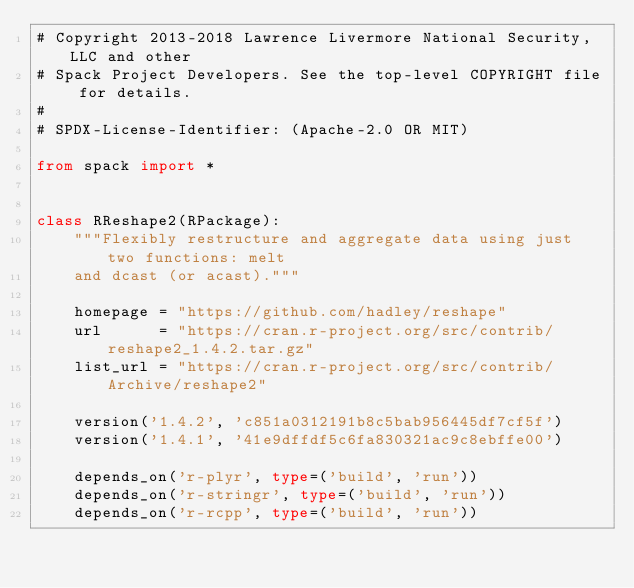Convert code to text. <code><loc_0><loc_0><loc_500><loc_500><_Python_># Copyright 2013-2018 Lawrence Livermore National Security, LLC and other
# Spack Project Developers. See the top-level COPYRIGHT file for details.
#
# SPDX-License-Identifier: (Apache-2.0 OR MIT)

from spack import *


class RReshape2(RPackage):
    """Flexibly restructure and aggregate data using just two functions: melt
    and dcast (or acast)."""

    homepage = "https://github.com/hadley/reshape"
    url      = "https://cran.r-project.org/src/contrib/reshape2_1.4.2.tar.gz"
    list_url = "https://cran.r-project.org/src/contrib/Archive/reshape2"

    version('1.4.2', 'c851a0312191b8c5bab956445df7cf5f')
    version('1.4.1', '41e9dffdf5c6fa830321ac9c8ebffe00')

    depends_on('r-plyr', type=('build', 'run'))
    depends_on('r-stringr', type=('build', 'run'))
    depends_on('r-rcpp', type=('build', 'run'))
</code> 